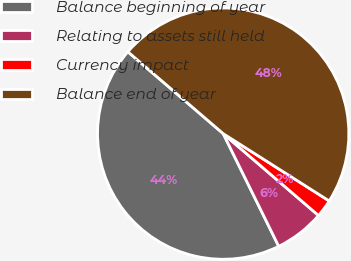Convert chart. <chart><loc_0><loc_0><loc_500><loc_500><pie_chart><fcel>Balance beginning of year<fcel>Relating to assets still held<fcel>Currency impact<fcel>Balance end of year<nl><fcel>43.58%<fcel>6.42%<fcel>2.29%<fcel>47.71%<nl></chart> 